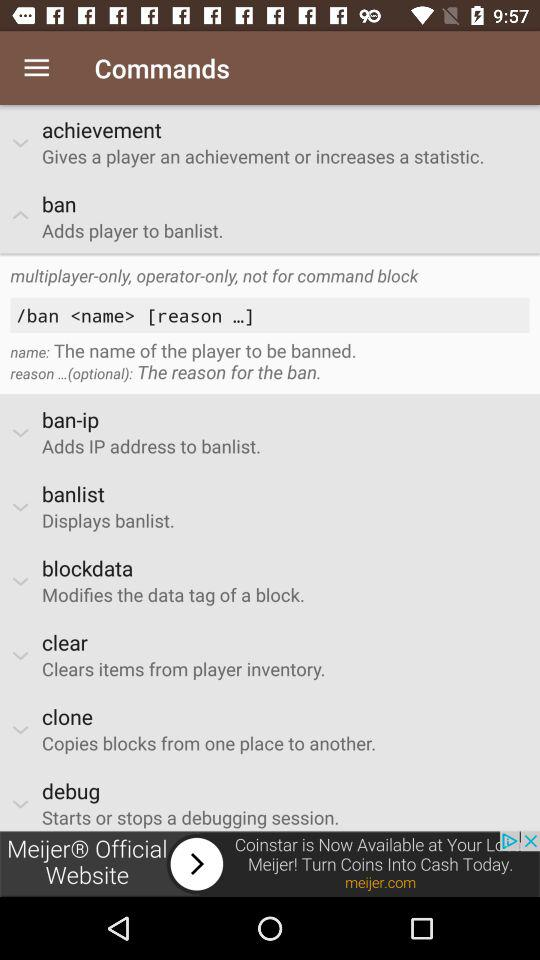What is the command to clear items from the player's inventory? The command is "clear". 